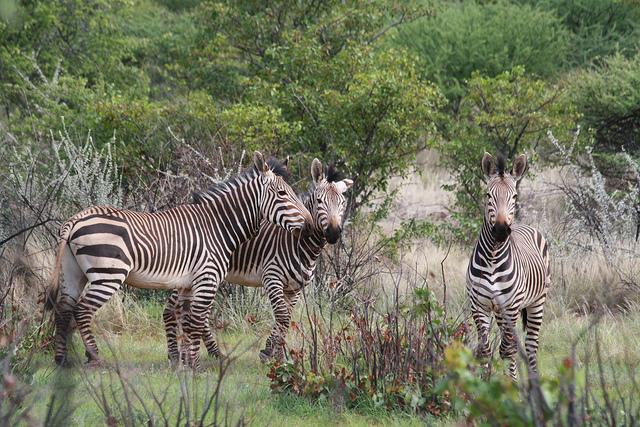Do all these zebras have all four of their legs on the ground?
Concise answer only. Yes. How many giraffes are in this picture?
Write a very short answer. 0. Is one zebra looking over the other zebra's back?
Give a very brief answer. No. What kind of animal is this?
Quick response, please. Zebra. How many zebras do you see?
Answer briefly. 3. 